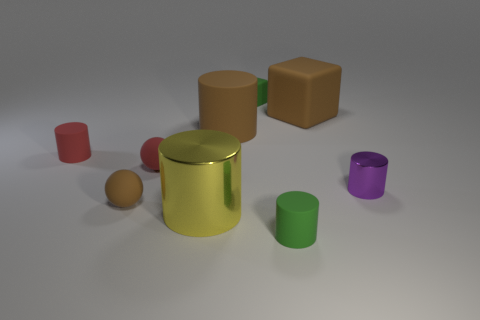Subtract all brown cylinders. How many cylinders are left? 4 Add 1 big yellow metallic things. How many objects exist? 10 Subtract all yellow cylinders. How many cylinders are left? 4 Subtract all purple cylinders. Subtract all green blocks. How many cylinders are left? 4 Subtract 1 yellow cylinders. How many objects are left? 8 Subtract all spheres. How many objects are left? 7 Subtract all green rubber things. Subtract all cyan things. How many objects are left? 7 Add 7 tiny brown matte spheres. How many tiny brown matte spheres are left? 8 Add 1 metallic cylinders. How many metallic cylinders exist? 3 